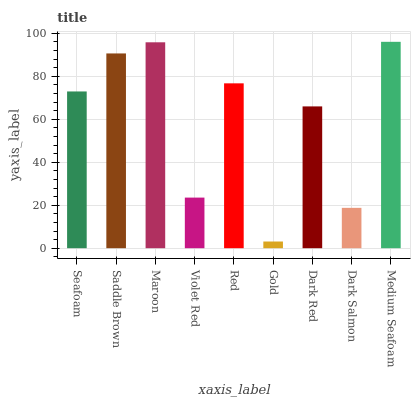Is Gold the minimum?
Answer yes or no. Yes. Is Medium Seafoam the maximum?
Answer yes or no. Yes. Is Saddle Brown the minimum?
Answer yes or no. No. Is Saddle Brown the maximum?
Answer yes or no. No. Is Saddle Brown greater than Seafoam?
Answer yes or no. Yes. Is Seafoam less than Saddle Brown?
Answer yes or no. Yes. Is Seafoam greater than Saddle Brown?
Answer yes or no. No. Is Saddle Brown less than Seafoam?
Answer yes or no. No. Is Seafoam the high median?
Answer yes or no. Yes. Is Seafoam the low median?
Answer yes or no. Yes. Is Gold the high median?
Answer yes or no. No. Is Saddle Brown the low median?
Answer yes or no. No. 